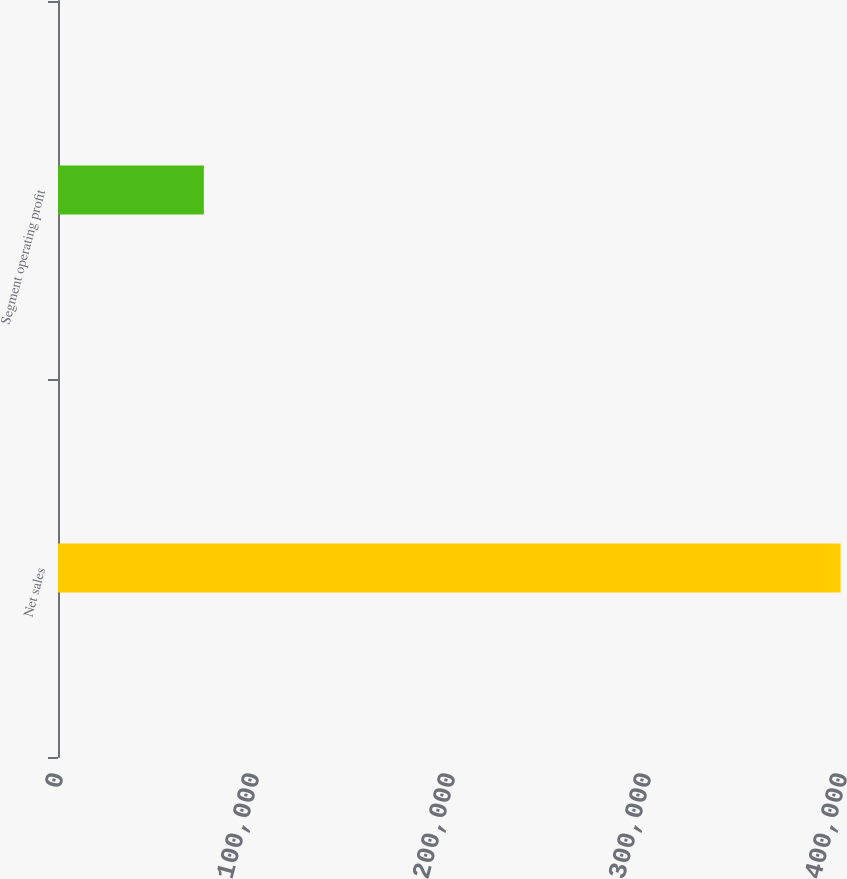Convert chart to OTSL. <chart><loc_0><loc_0><loc_500><loc_500><bar_chart><fcel>Net sales<fcel>Segment operating profit<nl><fcel>399276<fcel>74402<nl></chart> 